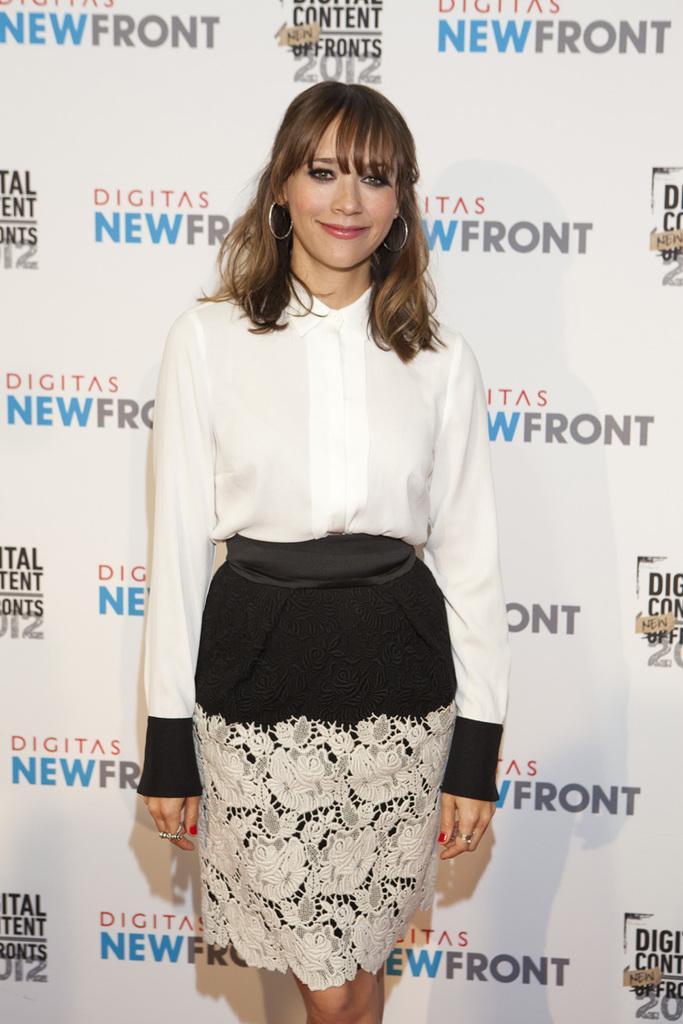How would you summarize this image in a sentence or two? In this picture there is a woman who is wearing white shirt and black short. She is standing near to the banner. She is smiling. In that banner we can see the quotations and logo. 